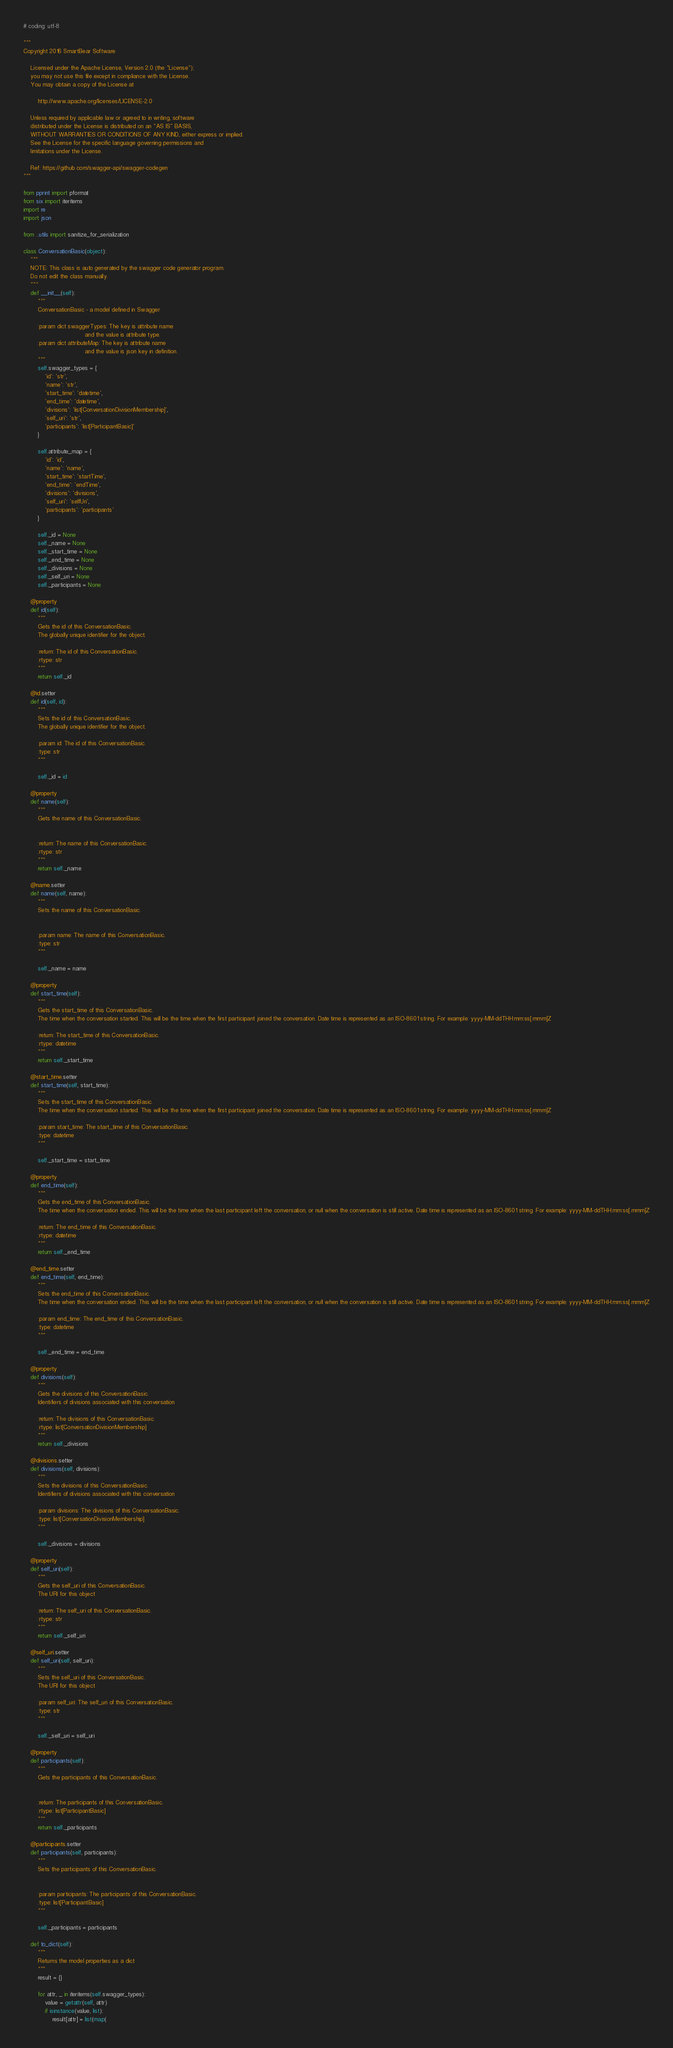Convert code to text. <code><loc_0><loc_0><loc_500><loc_500><_Python_># coding: utf-8

"""
Copyright 2016 SmartBear Software

    Licensed under the Apache License, Version 2.0 (the "License");
    you may not use this file except in compliance with the License.
    You may obtain a copy of the License at

        http://www.apache.org/licenses/LICENSE-2.0

    Unless required by applicable law or agreed to in writing, software
    distributed under the License is distributed on an "AS IS" BASIS,
    WITHOUT WARRANTIES OR CONDITIONS OF ANY KIND, either express or implied.
    See the License for the specific language governing permissions and
    limitations under the License.

    Ref: https://github.com/swagger-api/swagger-codegen
"""

from pprint import pformat
from six import iteritems
import re
import json

from ..utils import sanitize_for_serialization

class ConversationBasic(object):
    """
    NOTE: This class is auto generated by the swagger code generator program.
    Do not edit the class manually.
    """
    def __init__(self):
        """
        ConversationBasic - a model defined in Swagger

        :param dict swaggerTypes: The key is attribute name
                                  and the value is attribute type.
        :param dict attributeMap: The key is attribute name
                                  and the value is json key in definition.
        """
        self.swagger_types = {
            'id': 'str',
            'name': 'str',
            'start_time': 'datetime',
            'end_time': 'datetime',
            'divisions': 'list[ConversationDivisionMembership]',
            'self_uri': 'str',
            'participants': 'list[ParticipantBasic]'
        }

        self.attribute_map = {
            'id': 'id',
            'name': 'name',
            'start_time': 'startTime',
            'end_time': 'endTime',
            'divisions': 'divisions',
            'self_uri': 'selfUri',
            'participants': 'participants'
        }

        self._id = None
        self._name = None
        self._start_time = None
        self._end_time = None
        self._divisions = None
        self._self_uri = None
        self._participants = None

    @property
    def id(self):
        """
        Gets the id of this ConversationBasic.
        The globally unique identifier for the object.

        :return: The id of this ConversationBasic.
        :rtype: str
        """
        return self._id

    @id.setter
    def id(self, id):
        """
        Sets the id of this ConversationBasic.
        The globally unique identifier for the object.

        :param id: The id of this ConversationBasic.
        :type: str
        """
        
        self._id = id

    @property
    def name(self):
        """
        Gets the name of this ConversationBasic.


        :return: The name of this ConversationBasic.
        :rtype: str
        """
        return self._name

    @name.setter
    def name(self, name):
        """
        Sets the name of this ConversationBasic.


        :param name: The name of this ConversationBasic.
        :type: str
        """
        
        self._name = name

    @property
    def start_time(self):
        """
        Gets the start_time of this ConversationBasic.
        The time when the conversation started. This will be the time when the first participant joined the conversation. Date time is represented as an ISO-8601 string. For example: yyyy-MM-ddTHH:mm:ss[.mmm]Z

        :return: The start_time of this ConversationBasic.
        :rtype: datetime
        """
        return self._start_time

    @start_time.setter
    def start_time(self, start_time):
        """
        Sets the start_time of this ConversationBasic.
        The time when the conversation started. This will be the time when the first participant joined the conversation. Date time is represented as an ISO-8601 string. For example: yyyy-MM-ddTHH:mm:ss[.mmm]Z

        :param start_time: The start_time of this ConversationBasic.
        :type: datetime
        """
        
        self._start_time = start_time

    @property
    def end_time(self):
        """
        Gets the end_time of this ConversationBasic.
        The time when the conversation ended. This will be the time when the last participant left the conversation, or null when the conversation is still active. Date time is represented as an ISO-8601 string. For example: yyyy-MM-ddTHH:mm:ss[.mmm]Z

        :return: The end_time of this ConversationBasic.
        :rtype: datetime
        """
        return self._end_time

    @end_time.setter
    def end_time(self, end_time):
        """
        Sets the end_time of this ConversationBasic.
        The time when the conversation ended. This will be the time when the last participant left the conversation, or null when the conversation is still active. Date time is represented as an ISO-8601 string. For example: yyyy-MM-ddTHH:mm:ss[.mmm]Z

        :param end_time: The end_time of this ConversationBasic.
        :type: datetime
        """
        
        self._end_time = end_time

    @property
    def divisions(self):
        """
        Gets the divisions of this ConversationBasic.
        Identifiers of divisions associated with this conversation

        :return: The divisions of this ConversationBasic.
        :rtype: list[ConversationDivisionMembership]
        """
        return self._divisions

    @divisions.setter
    def divisions(self, divisions):
        """
        Sets the divisions of this ConversationBasic.
        Identifiers of divisions associated with this conversation

        :param divisions: The divisions of this ConversationBasic.
        :type: list[ConversationDivisionMembership]
        """
        
        self._divisions = divisions

    @property
    def self_uri(self):
        """
        Gets the self_uri of this ConversationBasic.
        The URI for this object

        :return: The self_uri of this ConversationBasic.
        :rtype: str
        """
        return self._self_uri

    @self_uri.setter
    def self_uri(self, self_uri):
        """
        Sets the self_uri of this ConversationBasic.
        The URI for this object

        :param self_uri: The self_uri of this ConversationBasic.
        :type: str
        """
        
        self._self_uri = self_uri

    @property
    def participants(self):
        """
        Gets the participants of this ConversationBasic.


        :return: The participants of this ConversationBasic.
        :rtype: list[ParticipantBasic]
        """
        return self._participants

    @participants.setter
    def participants(self, participants):
        """
        Sets the participants of this ConversationBasic.


        :param participants: The participants of this ConversationBasic.
        :type: list[ParticipantBasic]
        """
        
        self._participants = participants

    def to_dict(self):
        """
        Returns the model properties as a dict
        """
        result = {}

        for attr, _ in iteritems(self.swagger_types):
            value = getattr(self, attr)
            if isinstance(value, list):
                result[attr] = list(map(</code> 